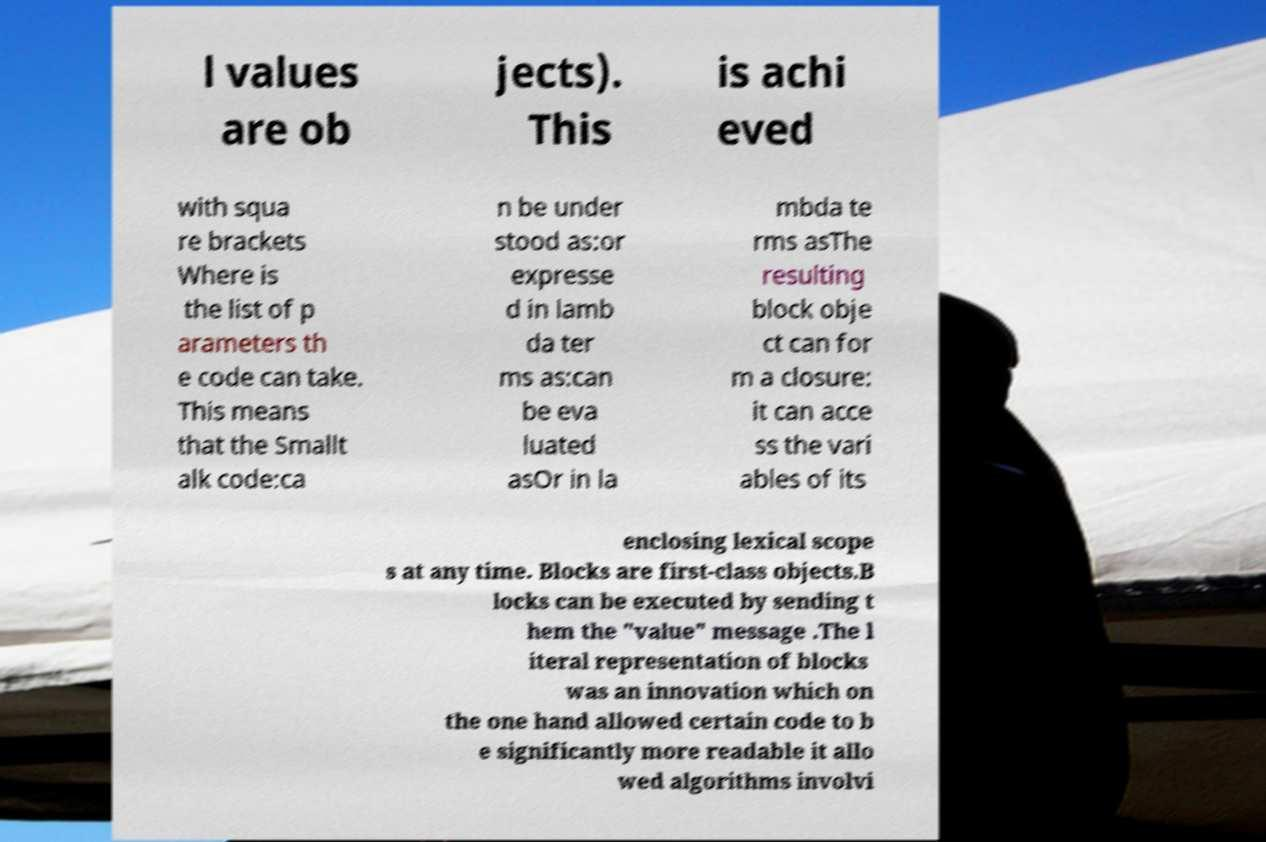Please identify and transcribe the text found in this image. l values are ob jects). This is achi eved with squa re brackets Where is the list of p arameters th e code can take. This means that the Smallt alk code:ca n be under stood as:or expresse d in lamb da ter ms as:can be eva luated asOr in la mbda te rms asThe resulting block obje ct can for m a closure: it can acce ss the vari ables of its enclosing lexical scope s at any time. Blocks are first-class objects.B locks can be executed by sending t hem the "value" message .The l iteral representation of blocks was an innovation which on the one hand allowed certain code to b e significantly more readable it allo wed algorithms involvi 